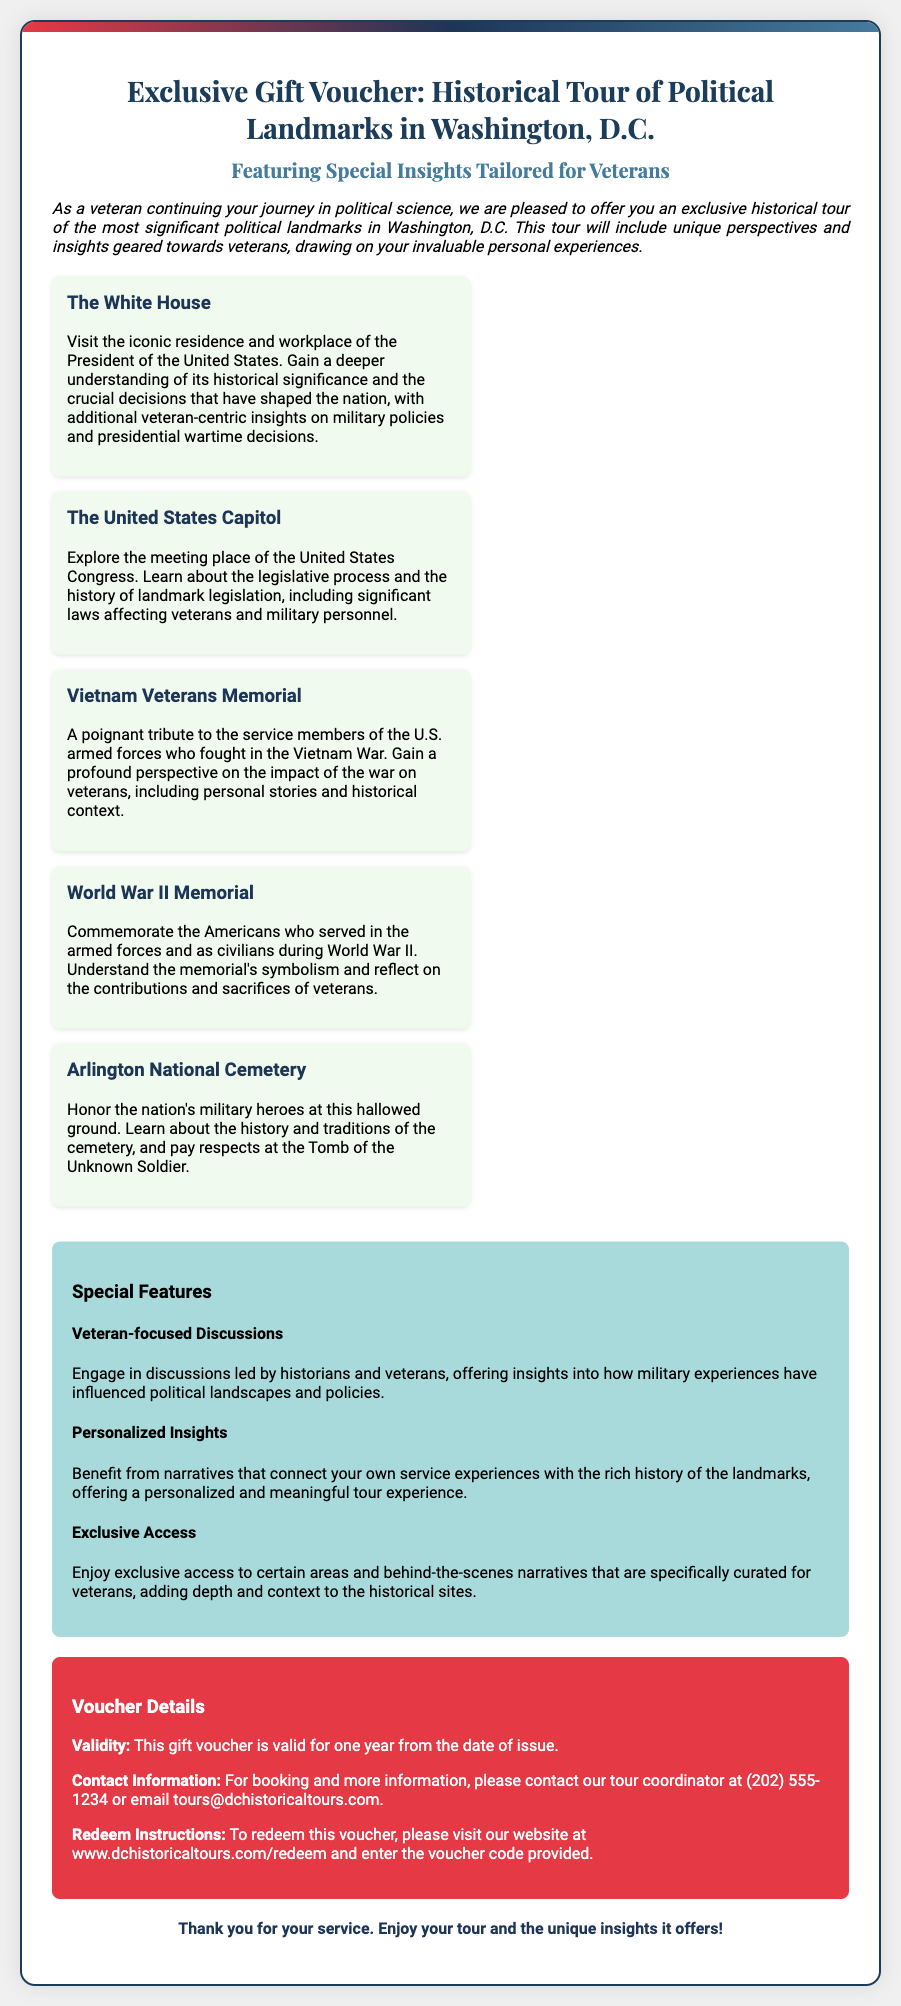What is the title of the voucher? The title of the voucher is presented prominently at the top of the document, stating its nature and purpose.
Answer: Exclusive Gift Voucher: Historical Tour of Political Landmarks in Washington, D.C How many landmarks are featured in the tour? The document lists multiple landmarks included in the tour, providing historical context for each one.
Answer: Five What is one of the special features mentioned? The document details various features of the tour, particularly those aimed at enhancing the veteran experience.
Answer: Veteran-focused Discussions Who can be contacted for more information? The contact information is clearly noted in the voucher details section for inquiries related to bookings.
Answer: Tour coordinator What is the validity period of the voucher? The validity period is specified in the details section, indicating how long the voucher can be used.
Answer: One year 